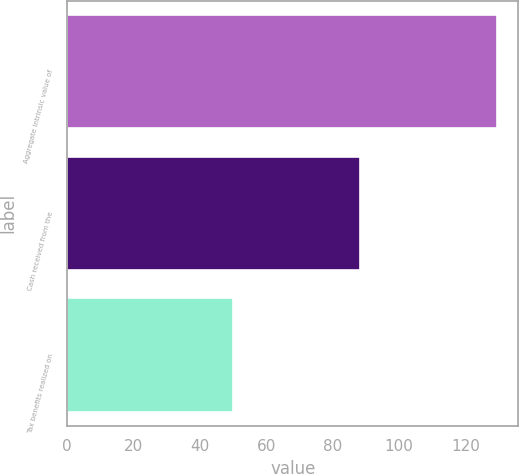Convert chart. <chart><loc_0><loc_0><loc_500><loc_500><bar_chart><fcel>Aggregate intrinsic value of<fcel>Cash received from the<fcel>Tax benefits realized on<nl><fcel>129.4<fcel>88.3<fcel>50<nl></chart> 